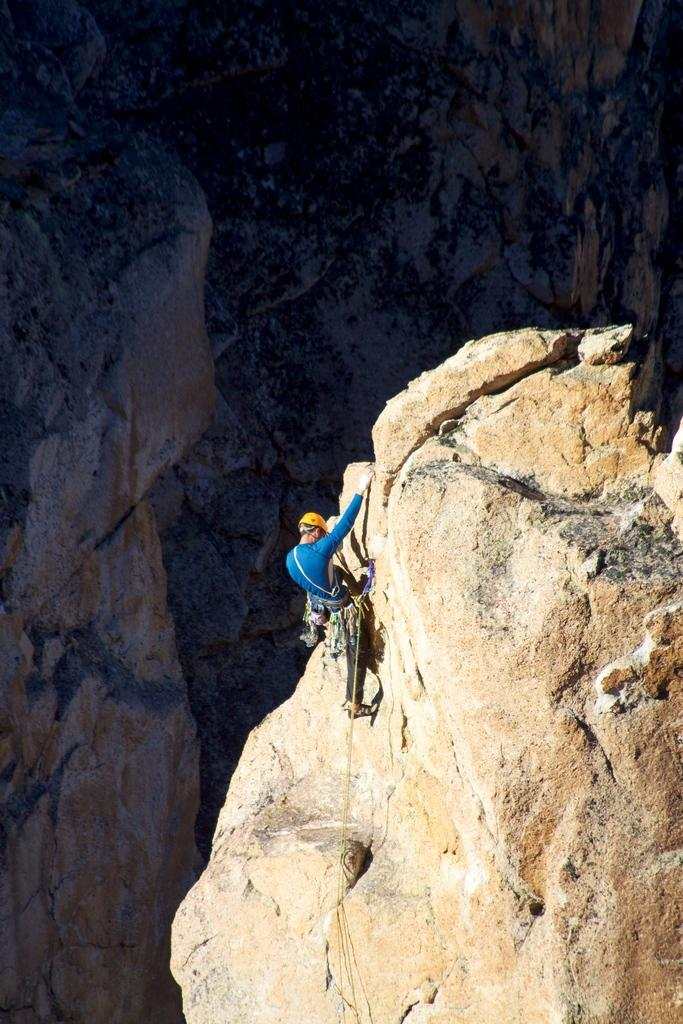Who or what is the main subject in the image? There is a person in the image. What is the person doing in the image? The person is climbing a mountain. What is the taste of the mountain in the image? The mountain does not have a taste, as it is a geographical feature and not a consumable item. 